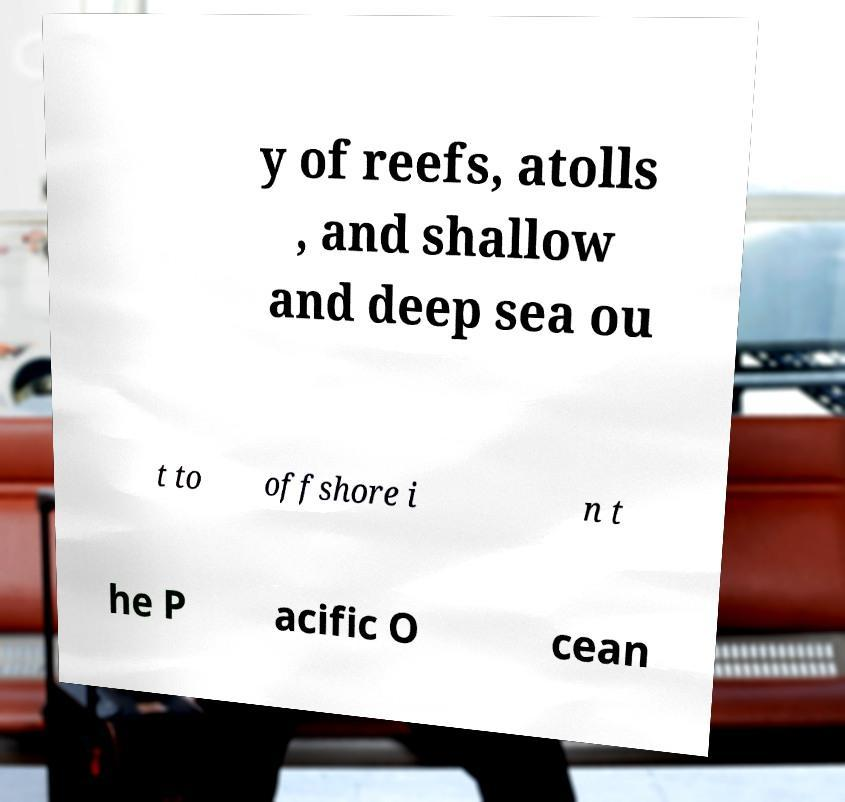For documentation purposes, I need the text within this image transcribed. Could you provide that? y of reefs, atolls , and shallow and deep sea ou t to offshore i n t he P acific O cean 